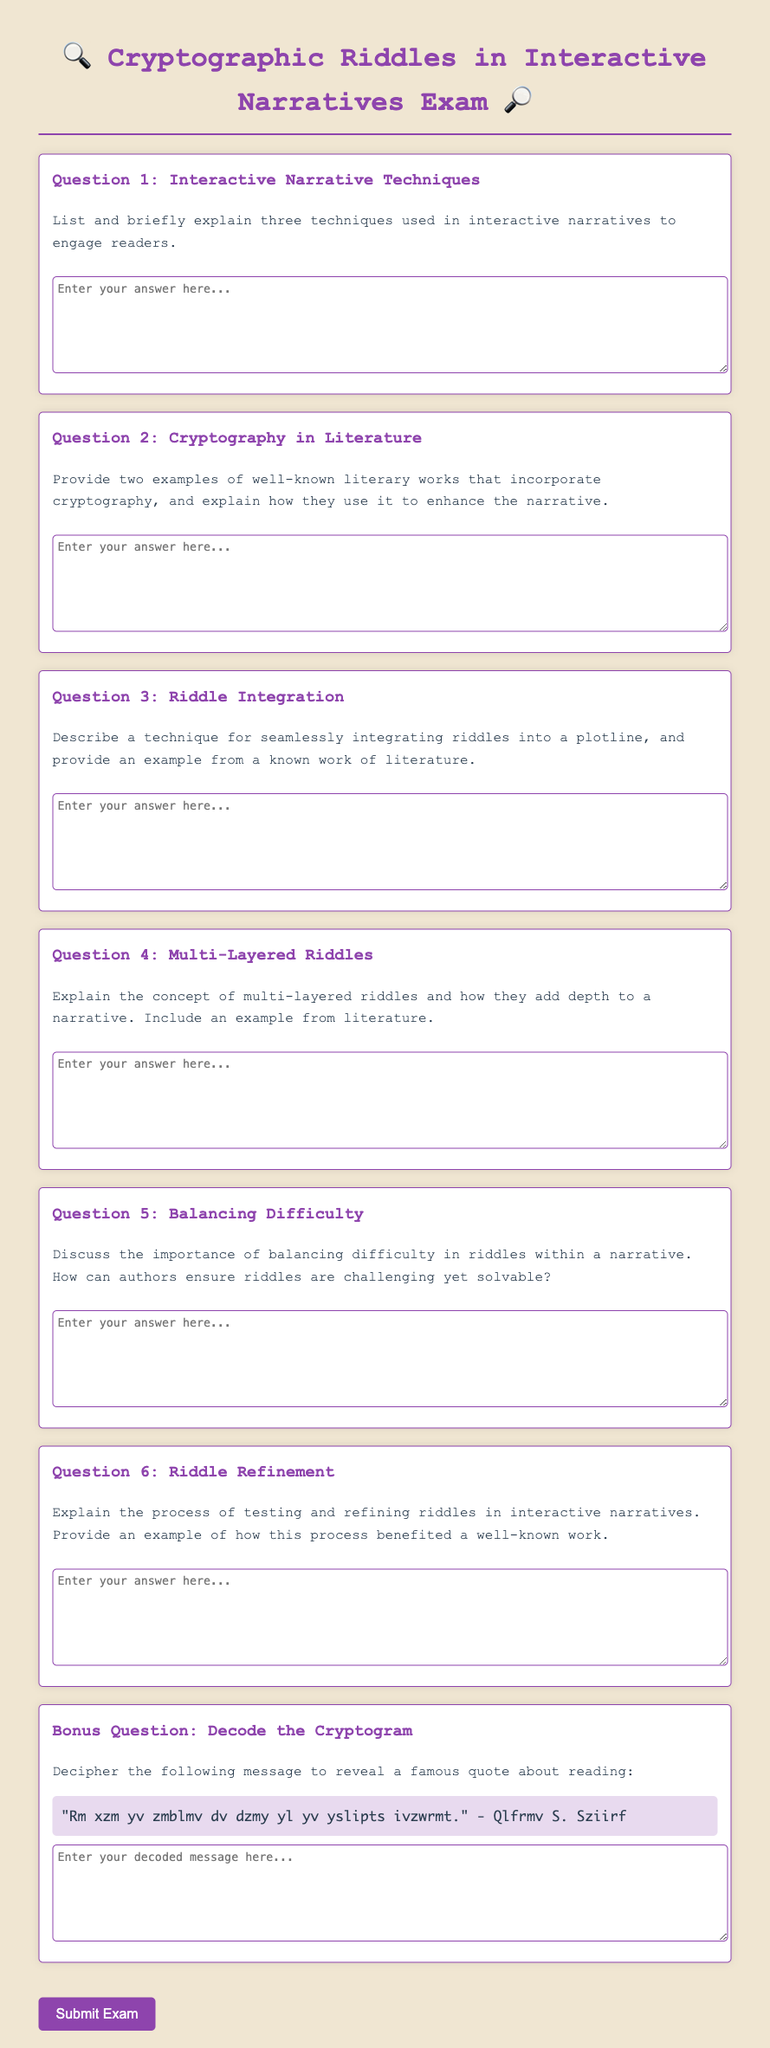What is the title of the exam? The title of the exam is stated in the HTML header section and prominently displayed at the top of the document.
Answer: Cryptographic Riddles in Interactive Narratives Exam How many main questions are included in the exam? The number of main questions can be found within the main content area of the HTML document.
Answer: 6 What color is used for the heading of the questions? The color of the headings for the questions is defined in the CSS styles for the question headings.
Answer: #8e44ad What is one technique for engaging readers mentioned in the first question? The first question asks for techniques but does not specify any; respondents would have to identify them from their knowledge.
Answer: (Varies by answer) What is the cryptogram included in Question 7? The cryptogram is provided in the bonus question of the exam, requiring decoding to reveal a famous quote.
Answer: "Rm xzm yv zmblmv dv dzmy yl yv yslipts ivzwrmt." - Qlfrmv S. Sziirf What type of questions follow the main prompt in the document? The questions are designed to elicit written responses, allowing for subjective answers from participants.
Answer: Short-answer questions What is the background color of the document? The background color is specified in the CSS style for the body element in the HTML document.
Answer: #f0e6d2 